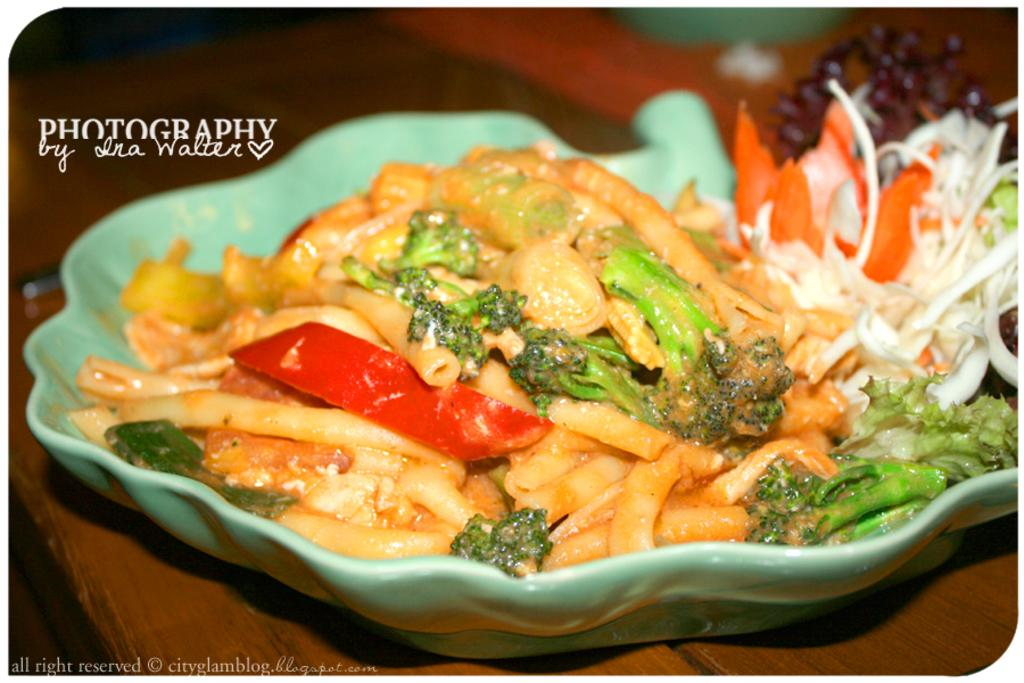What type of table is present at the bottom of the image? There is a wooden table at the bottom of the image. What is on the wooden table? There is a bowl of salad on the table. Where is the text located in the image? The text is in the top left of the image. How many pizzas are being served on the wooden table in the image? There is no mention of pizzas in the image; it features a bowl of salad on the table. 